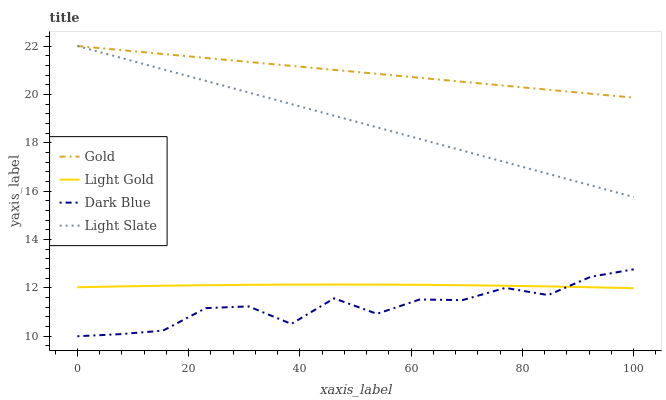Does Dark Blue have the minimum area under the curve?
Answer yes or no. Yes. Does Gold have the maximum area under the curve?
Answer yes or no. Yes. Does Light Gold have the minimum area under the curve?
Answer yes or no. No. Does Light Gold have the maximum area under the curve?
Answer yes or no. No. Is Gold the smoothest?
Answer yes or no. Yes. Is Dark Blue the roughest?
Answer yes or no. Yes. Is Light Gold the smoothest?
Answer yes or no. No. Is Light Gold the roughest?
Answer yes or no. No. Does Dark Blue have the lowest value?
Answer yes or no. Yes. Does Light Gold have the lowest value?
Answer yes or no. No. Does Gold have the highest value?
Answer yes or no. Yes. Does Dark Blue have the highest value?
Answer yes or no. No. Is Dark Blue less than Light Slate?
Answer yes or no. Yes. Is Gold greater than Dark Blue?
Answer yes or no. Yes. Does Gold intersect Light Slate?
Answer yes or no. Yes. Is Gold less than Light Slate?
Answer yes or no. No. Is Gold greater than Light Slate?
Answer yes or no. No. Does Dark Blue intersect Light Slate?
Answer yes or no. No. 